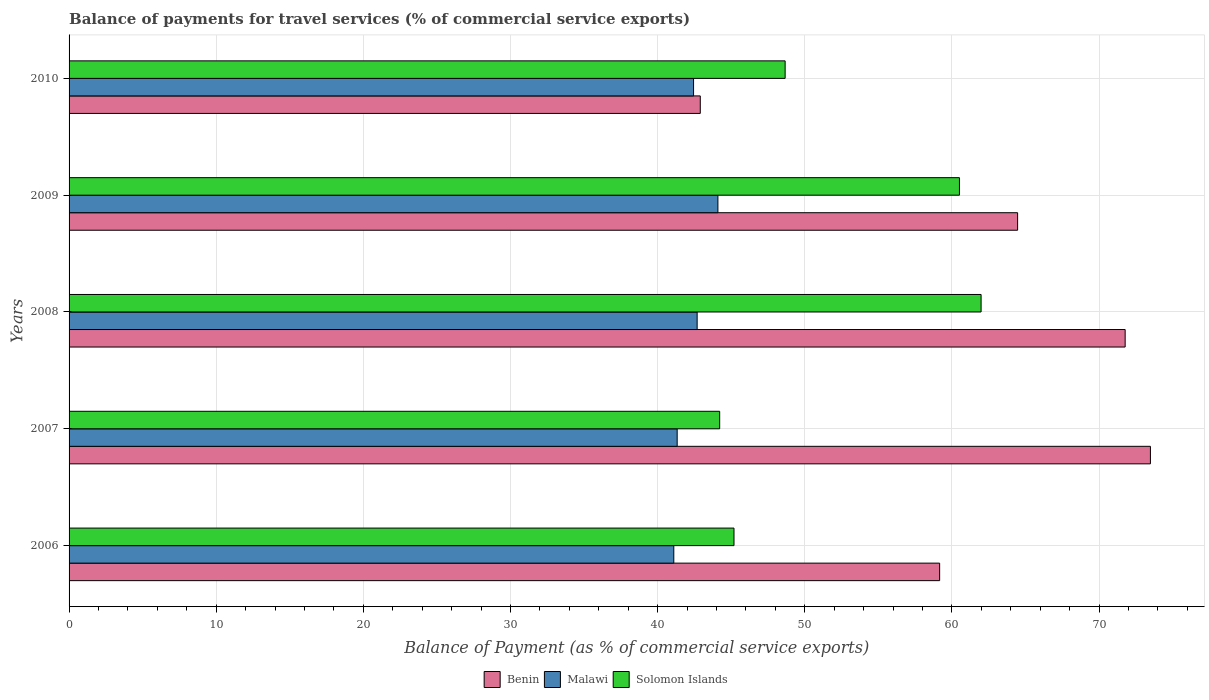How many different coloured bars are there?
Your response must be concise. 3. How many groups of bars are there?
Your answer should be very brief. 5. Are the number of bars per tick equal to the number of legend labels?
Keep it short and to the point. Yes. How many bars are there on the 1st tick from the bottom?
Offer a very short reply. 3. What is the label of the 1st group of bars from the top?
Keep it short and to the point. 2010. What is the balance of payments for travel services in Malawi in 2006?
Your response must be concise. 41.1. Across all years, what is the maximum balance of payments for travel services in Malawi?
Ensure brevity in your answer.  44.1. Across all years, what is the minimum balance of payments for travel services in Malawi?
Your response must be concise. 41.1. What is the total balance of payments for travel services in Benin in the graph?
Your answer should be very brief. 311.81. What is the difference between the balance of payments for travel services in Benin in 2007 and that in 2010?
Offer a terse response. 30.59. What is the difference between the balance of payments for travel services in Malawi in 2006 and the balance of payments for travel services in Solomon Islands in 2010?
Offer a terse response. -7.57. What is the average balance of payments for travel services in Malawi per year?
Offer a very short reply. 42.33. In the year 2009, what is the difference between the balance of payments for travel services in Malawi and balance of payments for travel services in Solomon Islands?
Make the answer very short. -16.42. In how many years, is the balance of payments for travel services in Solomon Islands greater than 74 %?
Keep it short and to the point. 0. What is the ratio of the balance of payments for travel services in Solomon Islands in 2008 to that in 2010?
Make the answer very short. 1.27. Is the balance of payments for travel services in Solomon Islands in 2009 less than that in 2010?
Provide a succinct answer. No. Is the difference between the balance of payments for travel services in Malawi in 2006 and 2009 greater than the difference between the balance of payments for travel services in Solomon Islands in 2006 and 2009?
Make the answer very short. Yes. What is the difference between the highest and the second highest balance of payments for travel services in Solomon Islands?
Ensure brevity in your answer.  1.47. What is the difference between the highest and the lowest balance of payments for travel services in Malawi?
Offer a very short reply. 3. In how many years, is the balance of payments for travel services in Malawi greater than the average balance of payments for travel services in Malawi taken over all years?
Offer a very short reply. 3. What does the 2nd bar from the top in 2007 represents?
Make the answer very short. Malawi. What does the 2nd bar from the bottom in 2007 represents?
Give a very brief answer. Malawi. Is it the case that in every year, the sum of the balance of payments for travel services in Benin and balance of payments for travel services in Solomon Islands is greater than the balance of payments for travel services in Malawi?
Your response must be concise. Yes. How many bars are there?
Offer a very short reply. 15. Are all the bars in the graph horizontal?
Your answer should be very brief. Yes. How many years are there in the graph?
Keep it short and to the point. 5. What is the difference between two consecutive major ticks on the X-axis?
Offer a very short reply. 10. Does the graph contain any zero values?
Make the answer very short. No. How many legend labels are there?
Offer a very short reply. 3. What is the title of the graph?
Your answer should be very brief. Balance of payments for travel services (% of commercial service exports). What is the label or title of the X-axis?
Your response must be concise. Balance of Payment (as % of commercial service exports). What is the label or title of the Y-axis?
Keep it short and to the point. Years. What is the Balance of Payment (as % of commercial service exports) of Benin in 2006?
Offer a very short reply. 59.17. What is the Balance of Payment (as % of commercial service exports) of Malawi in 2006?
Keep it short and to the point. 41.1. What is the Balance of Payment (as % of commercial service exports) of Solomon Islands in 2006?
Your answer should be compact. 45.19. What is the Balance of Payment (as % of commercial service exports) of Benin in 2007?
Make the answer very short. 73.49. What is the Balance of Payment (as % of commercial service exports) of Malawi in 2007?
Offer a terse response. 41.33. What is the Balance of Payment (as % of commercial service exports) in Solomon Islands in 2007?
Provide a short and direct response. 44.22. What is the Balance of Payment (as % of commercial service exports) in Benin in 2008?
Offer a very short reply. 71.78. What is the Balance of Payment (as % of commercial service exports) in Malawi in 2008?
Offer a terse response. 42.69. What is the Balance of Payment (as % of commercial service exports) of Solomon Islands in 2008?
Your answer should be compact. 61.99. What is the Balance of Payment (as % of commercial service exports) of Benin in 2009?
Provide a succinct answer. 64.47. What is the Balance of Payment (as % of commercial service exports) of Malawi in 2009?
Ensure brevity in your answer.  44.1. What is the Balance of Payment (as % of commercial service exports) of Solomon Islands in 2009?
Your response must be concise. 60.51. What is the Balance of Payment (as % of commercial service exports) of Benin in 2010?
Your answer should be very brief. 42.9. What is the Balance of Payment (as % of commercial service exports) of Malawi in 2010?
Offer a very short reply. 42.44. What is the Balance of Payment (as % of commercial service exports) in Solomon Islands in 2010?
Provide a short and direct response. 48.67. Across all years, what is the maximum Balance of Payment (as % of commercial service exports) of Benin?
Provide a succinct answer. 73.49. Across all years, what is the maximum Balance of Payment (as % of commercial service exports) in Malawi?
Your response must be concise. 44.1. Across all years, what is the maximum Balance of Payment (as % of commercial service exports) in Solomon Islands?
Give a very brief answer. 61.99. Across all years, what is the minimum Balance of Payment (as % of commercial service exports) in Benin?
Make the answer very short. 42.9. Across all years, what is the minimum Balance of Payment (as % of commercial service exports) of Malawi?
Provide a short and direct response. 41.1. Across all years, what is the minimum Balance of Payment (as % of commercial service exports) of Solomon Islands?
Your answer should be very brief. 44.22. What is the total Balance of Payment (as % of commercial service exports) in Benin in the graph?
Ensure brevity in your answer.  311.81. What is the total Balance of Payment (as % of commercial service exports) of Malawi in the graph?
Keep it short and to the point. 211.66. What is the total Balance of Payment (as % of commercial service exports) of Solomon Islands in the graph?
Make the answer very short. 260.58. What is the difference between the Balance of Payment (as % of commercial service exports) of Benin in 2006 and that in 2007?
Make the answer very short. -14.33. What is the difference between the Balance of Payment (as % of commercial service exports) of Malawi in 2006 and that in 2007?
Keep it short and to the point. -0.23. What is the difference between the Balance of Payment (as % of commercial service exports) in Solomon Islands in 2006 and that in 2007?
Your answer should be very brief. 0.97. What is the difference between the Balance of Payment (as % of commercial service exports) of Benin in 2006 and that in 2008?
Keep it short and to the point. -12.61. What is the difference between the Balance of Payment (as % of commercial service exports) in Malawi in 2006 and that in 2008?
Your response must be concise. -1.59. What is the difference between the Balance of Payment (as % of commercial service exports) in Solomon Islands in 2006 and that in 2008?
Your answer should be very brief. -16.79. What is the difference between the Balance of Payment (as % of commercial service exports) in Benin in 2006 and that in 2009?
Keep it short and to the point. -5.3. What is the difference between the Balance of Payment (as % of commercial service exports) of Malawi in 2006 and that in 2009?
Make the answer very short. -3. What is the difference between the Balance of Payment (as % of commercial service exports) of Solomon Islands in 2006 and that in 2009?
Ensure brevity in your answer.  -15.32. What is the difference between the Balance of Payment (as % of commercial service exports) of Benin in 2006 and that in 2010?
Keep it short and to the point. 16.27. What is the difference between the Balance of Payment (as % of commercial service exports) of Malawi in 2006 and that in 2010?
Your answer should be compact. -1.34. What is the difference between the Balance of Payment (as % of commercial service exports) in Solomon Islands in 2006 and that in 2010?
Your response must be concise. -3.48. What is the difference between the Balance of Payment (as % of commercial service exports) in Benin in 2007 and that in 2008?
Ensure brevity in your answer.  1.72. What is the difference between the Balance of Payment (as % of commercial service exports) in Malawi in 2007 and that in 2008?
Offer a very short reply. -1.36. What is the difference between the Balance of Payment (as % of commercial service exports) of Solomon Islands in 2007 and that in 2008?
Give a very brief answer. -17.77. What is the difference between the Balance of Payment (as % of commercial service exports) in Benin in 2007 and that in 2009?
Offer a very short reply. 9.03. What is the difference between the Balance of Payment (as % of commercial service exports) of Malawi in 2007 and that in 2009?
Provide a short and direct response. -2.77. What is the difference between the Balance of Payment (as % of commercial service exports) of Solomon Islands in 2007 and that in 2009?
Ensure brevity in your answer.  -16.3. What is the difference between the Balance of Payment (as % of commercial service exports) in Benin in 2007 and that in 2010?
Provide a short and direct response. 30.59. What is the difference between the Balance of Payment (as % of commercial service exports) in Malawi in 2007 and that in 2010?
Ensure brevity in your answer.  -1.11. What is the difference between the Balance of Payment (as % of commercial service exports) in Solomon Islands in 2007 and that in 2010?
Make the answer very short. -4.45. What is the difference between the Balance of Payment (as % of commercial service exports) of Benin in 2008 and that in 2009?
Your answer should be very brief. 7.31. What is the difference between the Balance of Payment (as % of commercial service exports) of Malawi in 2008 and that in 2009?
Make the answer very short. -1.41. What is the difference between the Balance of Payment (as % of commercial service exports) in Solomon Islands in 2008 and that in 2009?
Keep it short and to the point. 1.47. What is the difference between the Balance of Payment (as % of commercial service exports) in Benin in 2008 and that in 2010?
Provide a short and direct response. 28.88. What is the difference between the Balance of Payment (as % of commercial service exports) of Malawi in 2008 and that in 2010?
Your response must be concise. 0.24. What is the difference between the Balance of Payment (as % of commercial service exports) of Solomon Islands in 2008 and that in 2010?
Your answer should be very brief. 13.32. What is the difference between the Balance of Payment (as % of commercial service exports) in Benin in 2009 and that in 2010?
Provide a short and direct response. 21.57. What is the difference between the Balance of Payment (as % of commercial service exports) of Malawi in 2009 and that in 2010?
Offer a terse response. 1.66. What is the difference between the Balance of Payment (as % of commercial service exports) in Solomon Islands in 2009 and that in 2010?
Your response must be concise. 11.85. What is the difference between the Balance of Payment (as % of commercial service exports) in Benin in 2006 and the Balance of Payment (as % of commercial service exports) in Malawi in 2007?
Your answer should be compact. 17.84. What is the difference between the Balance of Payment (as % of commercial service exports) of Benin in 2006 and the Balance of Payment (as % of commercial service exports) of Solomon Islands in 2007?
Provide a succinct answer. 14.95. What is the difference between the Balance of Payment (as % of commercial service exports) in Malawi in 2006 and the Balance of Payment (as % of commercial service exports) in Solomon Islands in 2007?
Offer a very short reply. -3.12. What is the difference between the Balance of Payment (as % of commercial service exports) in Benin in 2006 and the Balance of Payment (as % of commercial service exports) in Malawi in 2008?
Give a very brief answer. 16.48. What is the difference between the Balance of Payment (as % of commercial service exports) in Benin in 2006 and the Balance of Payment (as % of commercial service exports) in Solomon Islands in 2008?
Make the answer very short. -2.82. What is the difference between the Balance of Payment (as % of commercial service exports) of Malawi in 2006 and the Balance of Payment (as % of commercial service exports) of Solomon Islands in 2008?
Make the answer very short. -20.89. What is the difference between the Balance of Payment (as % of commercial service exports) of Benin in 2006 and the Balance of Payment (as % of commercial service exports) of Malawi in 2009?
Your answer should be compact. 15.07. What is the difference between the Balance of Payment (as % of commercial service exports) in Benin in 2006 and the Balance of Payment (as % of commercial service exports) in Solomon Islands in 2009?
Give a very brief answer. -1.35. What is the difference between the Balance of Payment (as % of commercial service exports) in Malawi in 2006 and the Balance of Payment (as % of commercial service exports) in Solomon Islands in 2009?
Make the answer very short. -19.41. What is the difference between the Balance of Payment (as % of commercial service exports) in Benin in 2006 and the Balance of Payment (as % of commercial service exports) in Malawi in 2010?
Provide a short and direct response. 16.73. What is the difference between the Balance of Payment (as % of commercial service exports) in Benin in 2006 and the Balance of Payment (as % of commercial service exports) in Solomon Islands in 2010?
Offer a terse response. 10.5. What is the difference between the Balance of Payment (as % of commercial service exports) of Malawi in 2006 and the Balance of Payment (as % of commercial service exports) of Solomon Islands in 2010?
Provide a short and direct response. -7.57. What is the difference between the Balance of Payment (as % of commercial service exports) in Benin in 2007 and the Balance of Payment (as % of commercial service exports) in Malawi in 2008?
Offer a very short reply. 30.81. What is the difference between the Balance of Payment (as % of commercial service exports) in Benin in 2007 and the Balance of Payment (as % of commercial service exports) in Solomon Islands in 2008?
Keep it short and to the point. 11.51. What is the difference between the Balance of Payment (as % of commercial service exports) of Malawi in 2007 and the Balance of Payment (as % of commercial service exports) of Solomon Islands in 2008?
Your response must be concise. -20.66. What is the difference between the Balance of Payment (as % of commercial service exports) in Benin in 2007 and the Balance of Payment (as % of commercial service exports) in Malawi in 2009?
Provide a succinct answer. 29.4. What is the difference between the Balance of Payment (as % of commercial service exports) of Benin in 2007 and the Balance of Payment (as % of commercial service exports) of Solomon Islands in 2009?
Ensure brevity in your answer.  12.98. What is the difference between the Balance of Payment (as % of commercial service exports) in Malawi in 2007 and the Balance of Payment (as % of commercial service exports) in Solomon Islands in 2009?
Offer a terse response. -19.19. What is the difference between the Balance of Payment (as % of commercial service exports) in Benin in 2007 and the Balance of Payment (as % of commercial service exports) in Malawi in 2010?
Keep it short and to the point. 31.05. What is the difference between the Balance of Payment (as % of commercial service exports) in Benin in 2007 and the Balance of Payment (as % of commercial service exports) in Solomon Islands in 2010?
Give a very brief answer. 24.83. What is the difference between the Balance of Payment (as % of commercial service exports) in Malawi in 2007 and the Balance of Payment (as % of commercial service exports) in Solomon Islands in 2010?
Provide a succinct answer. -7.34. What is the difference between the Balance of Payment (as % of commercial service exports) in Benin in 2008 and the Balance of Payment (as % of commercial service exports) in Malawi in 2009?
Provide a short and direct response. 27.68. What is the difference between the Balance of Payment (as % of commercial service exports) in Benin in 2008 and the Balance of Payment (as % of commercial service exports) in Solomon Islands in 2009?
Your response must be concise. 11.26. What is the difference between the Balance of Payment (as % of commercial service exports) of Malawi in 2008 and the Balance of Payment (as % of commercial service exports) of Solomon Islands in 2009?
Your answer should be compact. -17.83. What is the difference between the Balance of Payment (as % of commercial service exports) in Benin in 2008 and the Balance of Payment (as % of commercial service exports) in Malawi in 2010?
Give a very brief answer. 29.33. What is the difference between the Balance of Payment (as % of commercial service exports) in Benin in 2008 and the Balance of Payment (as % of commercial service exports) in Solomon Islands in 2010?
Your response must be concise. 23.11. What is the difference between the Balance of Payment (as % of commercial service exports) in Malawi in 2008 and the Balance of Payment (as % of commercial service exports) in Solomon Islands in 2010?
Your response must be concise. -5.98. What is the difference between the Balance of Payment (as % of commercial service exports) in Benin in 2009 and the Balance of Payment (as % of commercial service exports) in Malawi in 2010?
Your answer should be compact. 22.02. What is the difference between the Balance of Payment (as % of commercial service exports) in Benin in 2009 and the Balance of Payment (as % of commercial service exports) in Solomon Islands in 2010?
Your answer should be very brief. 15.8. What is the difference between the Balance of Payment (as % of commercial service exports) of Malawi in 2009 and the Balance of Payment (as % of commercial service exports) of Solomon Islands in 2010?
Your answer should be compact. -4.57. What is the average Balance of Payment (as % of commercial service exports) in Benin per year?
Make the answer very short. 62.36. What is the average Balance of Payment (as % of commercial service exports) in Malawi per year?
Your response must be concise. 42.33. What is the average Balance of Payment (as % of commercial service exports) in Solomon Islands per year?
Keep it short and to the point. 52.12. In the year 2006, what is the difference between the Balance of Payment (as % of commercial service exports) of Benin and Balance of Payment (as % of commercial service exports) of Malawi?
Provide a short and direct response. 18.07. In the year 2006, what is the difference between the Balance of Payment (as % of commercial service exports) of Benin and Balance of Payment (as % of commercial service exports) of Solomon Islands?
Ensure brevity in your answer.  13.98. In the year 2006, what is the difference between the Balance of Payment (as % of commercial service exports) of Malawi and Balance of Payment (as % of commercial service exports) of Solomon Islands?
Your response must be concise. -4.09. In the year 2007, what is the difference between the Balance of Payment (as % of commercial service exports) in Benin and Balance of Payment (as % of commercial service exports) in Malawi?
Give a very brief answer. 32.16. In the year 2007, what is the difference between the Balance of Payment (as % of commercial service exports) of Benin and Balance of Payment (as % of commercial service exports) of Solomon Islands?
Offer a terse response. 29.28. In the year 2007, what is the difference between the Balance of Payment (as % of commercial service exports) of Malawi and Balance of Payment (as % of commercial service exports) of Solomon Islands?
Keep it short and to the point. -2.89. In the year 2008, what is the difference between the Balance of Payment (as % of commercial service exports) in Benin and Balance of Payment (as % of commercial service exports) in Malawi?
Your answer should be very brief. 29.09. In the year 2008, what is the difference between the Balance of Payment (as % of commercial service exports) in Benin and Balance of Payment (as % of commercial service exports) in Solomon Islands?
Provide a short and direct response. 9.79. In the year 2008, what is the difference between the Balance of Payment (as % of commercial service exports) of Malawi and Balance of Payment (as % of commercial service exports) of Solomon Islands?
Your answer should be compact. -19.3. In the year 2009, what is the difference between the Balance of Payment (as % of commercial service exports) of Benin and Balance of Payment (as % of commercial service exports) of Malawi?
Offer a very short reply. 20.37. In the year 2009, what is the difference between the Balance of Payment (as % of commercial service exports) in Benin and Balance of Payment (as % of commercial service exports) in Solomon Islands?
Ensure brevity in your answer.  3.95. In the year 2009, what is the difference between the Balance of Payment (as % of commercial service exports) in Malawi and Balance of Payment (as % of commercial service exports) in Solomon Islands?
Your answer should be very brief. -16.42. In the year 2010, what is the difference between the Balance of Payment (as % of commercial service exports) of Benin and Balance of Payment (as % of commercial service exports) of Malawi?
Keep it short and to the point. 0.46. In the year 2010, what is the difference between the Balance of Payment (as % of commercial service exports) in Benin and Balance of Payment (as % of commercial service exports) in Solomon Islands?
Make the answer very short. -5.77. In the year 2010, what is the difference between the Balance of Payment (as % of commercial service exports) in Malawi and Balance of Payment (as % of commercial service exports) in Solomon Islands?
Give a very brief answer. -6.22. What is the ratio of the Balance of Payment (as % of commercial service exports) in Benin in 2006 to that in 2007?
Offer a very short reply. 0.81. What is the ratio of the Balance of Payment (as % of commercial service exports) in Benin in 2006 to that in 2008?
Make the answer very short. 0.82. What is the ratio of the Balance of Payment (as % of commercial service exports) of Malawi in 2006 to that in 2008?
Provide a short and direct response. 0.96. What is the ratio of the Balance of Payment (as % of commercial service exports) in Solomon Islands in 2006 to that in 2008?
Provide a succinct answer. 0.73. What is the ratio of the Balance of Payment (as % of commercial service exports) in Benin in 2006 to that in 2009?
Give a very brief answer. 0.92. What is the ratio of the Balance of Payment (as % of commercial service exports) of Malawi in 2006 to that in 2009?
Provide a short and direct response. 0.93. What is the ratio of the Balance of Payment (as % of commercial service exports) of Solomon Islands in 2006 to that in 2009?
Provide a succinct answer. 0.75. What is the ratio of the Balance of Payment (as % of commercial service exports) in Benin in 2006 to that in 2010?
Give a very brief answer. 1.38. What is the ratio of the Balance of Payment (as % of commercial service exports) of Malawi in 2006 to that in 2010?
Keep it short and to the point. 0.97. What is the ratio of the Balance of Payment (as % of commercial service exports) in Benin in 2007 to that in 2008?
Your answer should be compact. 1.02. What is the ratio of the Balance of Payment (as % of commercial service exports) in Malawi in 2007 to that in 2008?
Provide a short and direct response. 0.97. What is the ratio of the Balance of Payment (as % of commercial service exports) in Solomon Islands in 2007 to that in 2008?
Make the answer very short. 0.71. What is the ratio of the Balance of Payment (as % of commercial service exports) of Benin in 2007 to that in 2009?
Give a very brief answer. 1.14. What is the ratio of the Balance of Payment (as % of commercial service exports) of Malawi in 2007 to that in 2009?
Keep it short and to the point. 0.94. What is the ratio of the Balance of Payment (as % of commercial service exports) in Solomon Islands in 2007 to that in 2009?
Ensure brevity in your answer.  0.73. What is the ratio of the Balance of Payment (as % of commercial service exports) of Benin in 2007 to that in 2010?
Offer a very short reply. 1.71. What is the ratio of the Balance of Payment (as % of commercial service exports) in Malawi in 2007 to that in 2010?
Keep it short and to the point. 0.97. What is the ratio of the Balance of Payment (as % of commercial service exports) of Solomon Islands in 2007 to that in 2010?
Provide a short and direct response. 0.91. What is the ratio of the Balance of Payment (as % of commercial service exports) of Benin in 2008 to that in 2009?
Give a very brief answer. 1.11. What is the ratio of the Balance of Payment (as % of commercial service exports) of Malawi in 2008 to that in 2009?
Offer a terse response. 0.97. What is the ratio of the Balance of Payment (as % of commercial service exports) in Solomon Islands in 2008 to that in 2009?
Your response must be concise. 1.02. What is the ratio of the Balance of Payment (as % of commercial service exports) of Benin in 2008 to that in 2010?
Give a very brief answer. 1.67. What is the ratio of the Balance of Payment (as % of commercial service exports) in Malawi in 2008 to that in 2010?
Your response must be concise. 1.01. What is the ratio of the Balance of Payment (as % of commercial service exports) in Solomon Islands in 2008 to that in 2010?
Your answer should be compact. 1.27. What is the ratio of the Balance of Payment (as % of commercial service exports) in Benin in 2009 to that in 2010?
Ensure brevity in your answer.  1.5. What is the ratio of the Balance of Payment (as % of commercial service exports) of Malawi in 2009 to that in 2010?
Ensure brevity in your answer.  1.04. What is the ratio of the Balance of Payment (as % of commercial service exports) of Solomon Islands in 2009 to that in 2010?
Keep it short and to the point. 1.24. What is the difference between the highest and the second highest Balance of Payment (as % of commercial service exports) in Benin?
Offer a terse response. 1.72. What is the difference between the highest and the second highest Balance of Payment (as % of commercial service exports) of Malawi?
Offer a very short reply. 1.41. What is the difference between the highest and the second highest Balance of Payment (as % of commercial service exports) in Solomon Islands?
Make the answer very short. 1.47. What is the difference between the highest and the lowest Balance of Payment (as % of commercial service exports) in Benin?
Make the answer very short. 30.59. What is the difference between the highest and the lowest Balance of Payment (as % of commercial service exports) of Malawi?
Give a very brief answer. 3. What is the difference between the highest and the lowest Balance of Payment (as % of commercial service exports) of Solomon Islands?
Offer a terse response. 17.77. 